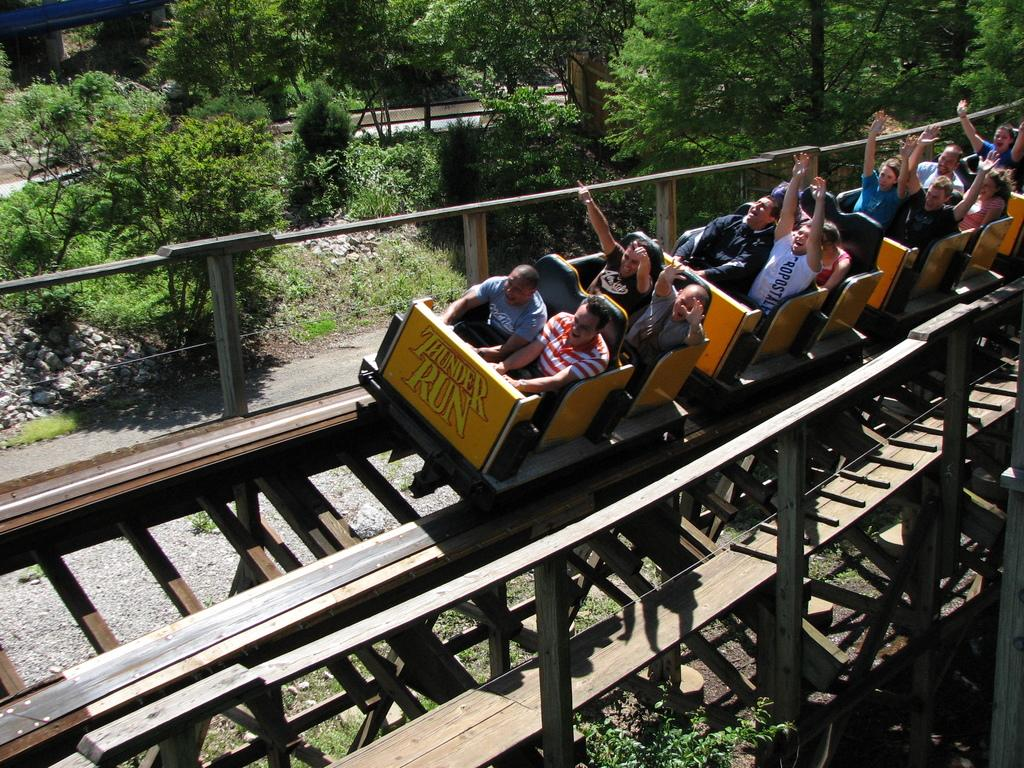<image>
Share a concise interpretation of the image provided. A roller coaster ride called Thunder Run barrels down the track with happy customers 